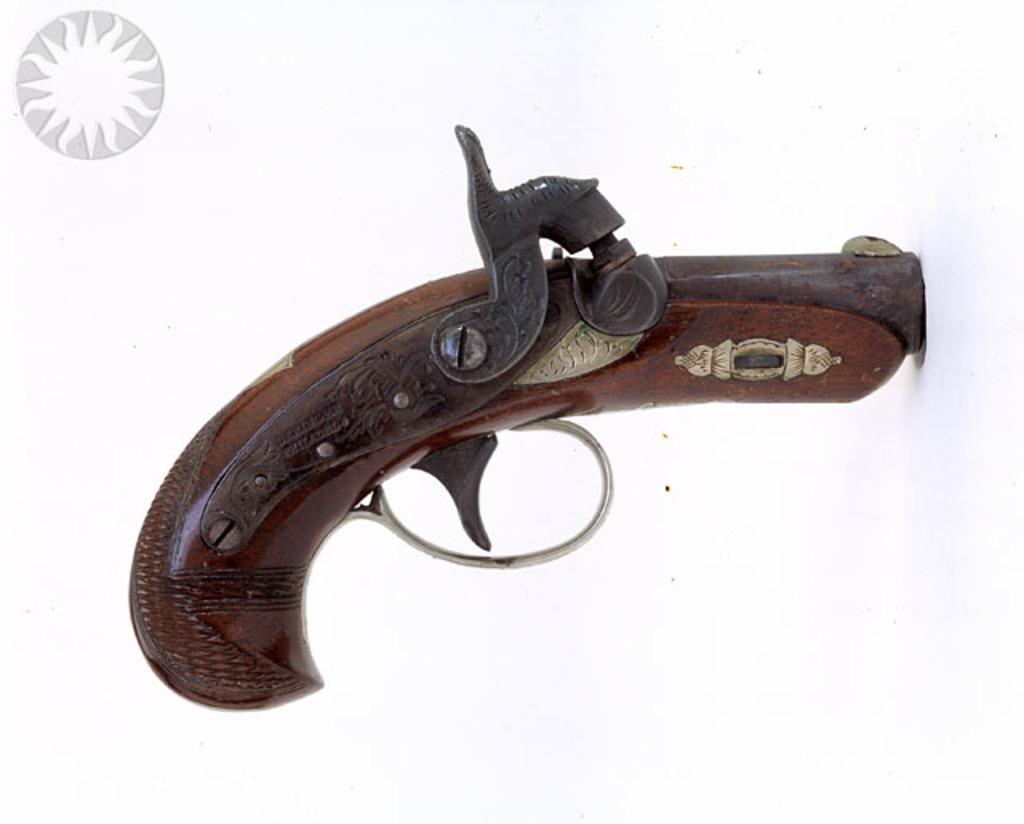In one or two sentences, can you explain what this image depicts? In this image I can see a gun. At the top left hand side I can see a picture. The background is white in color. 